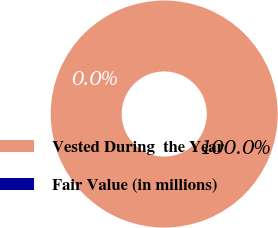Convert chart to OTSL. <chart><loc_0><loc_0><loc_500><loc_500><pie_chart><fcel>Vested During  the Year<fcel>Fair Value (in millions)<nl><fcel>100.0%<fcel>0.0%<nl></chart> 